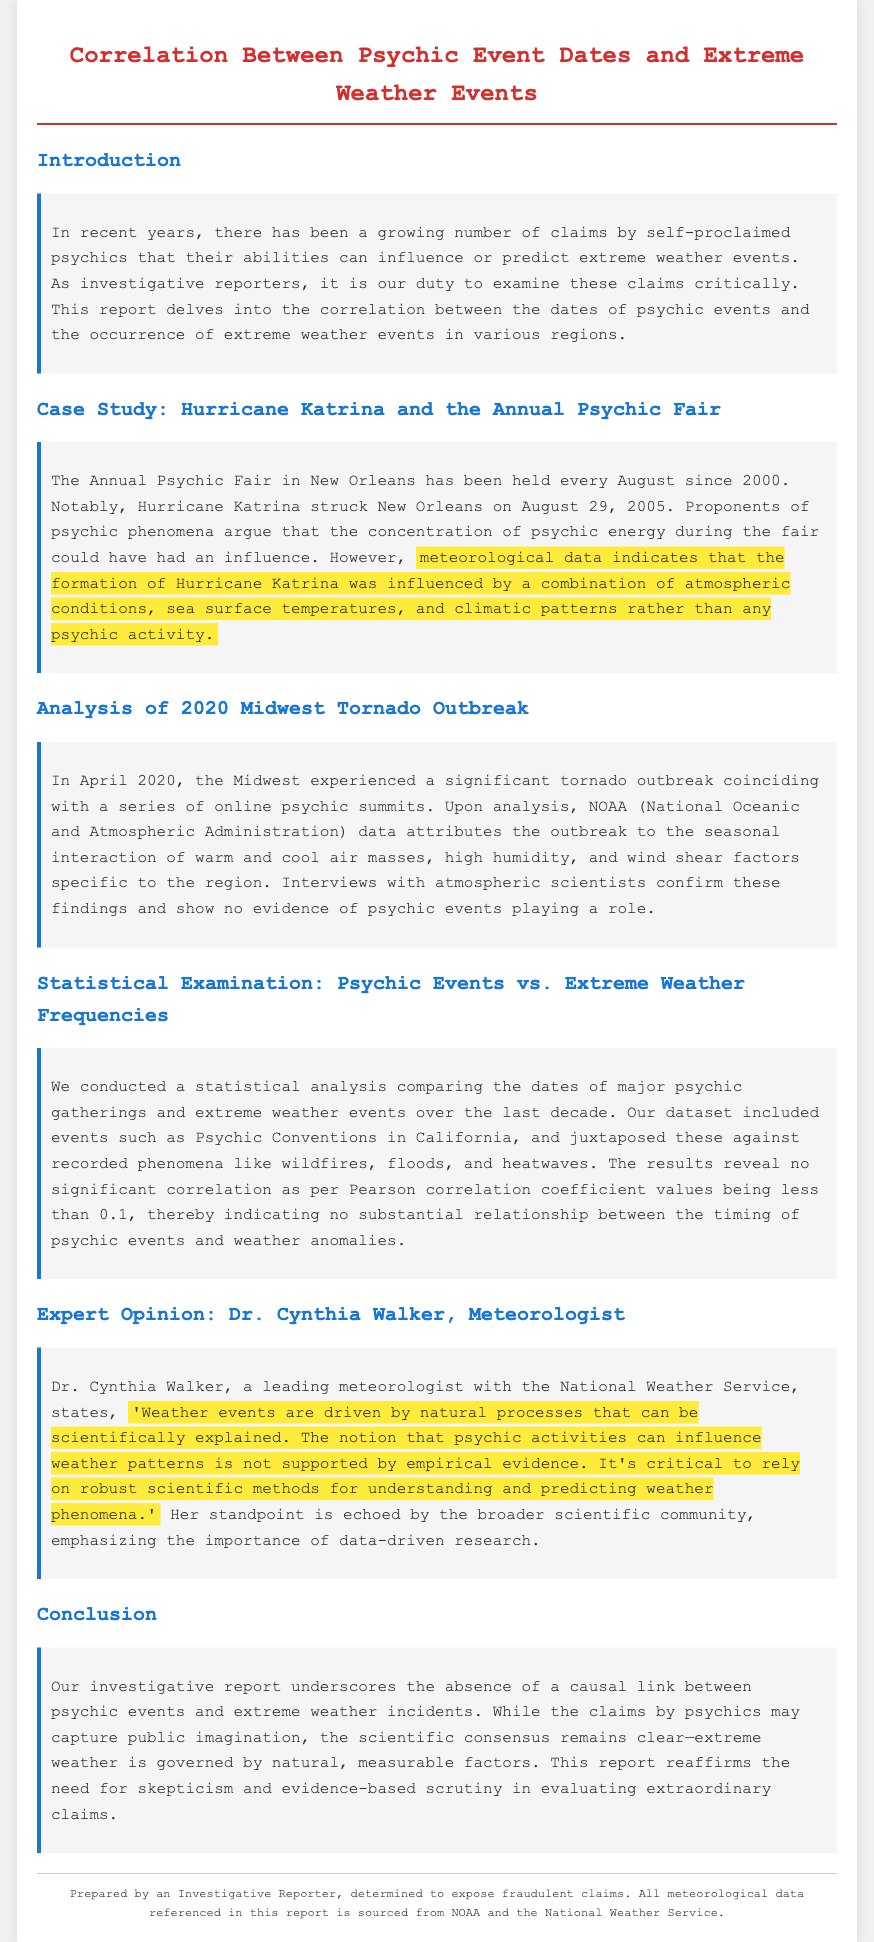What event coincided with Hurricane Katrina? The report indicates that Hurricane Katrina struck New Orleans on August 29, 2005, coinciding with the Annual Psychic Fair held every August since 2000.
Answer: Annual Psychic Fair What does the Pearson correlation coefficient indicate in this report? The report states that the Pearson correlation coefficient values being less than 0.1 indicate no substantial relationship between the timing of psychic events and weather anomalies.
Answer: Less than 0.1 Who is Dr. Cynthia Walker? Dr. Cynthia Walker is identified as a leading meteorologist with the National Weather Service in the document.
Answer: Leading meteorologist What significant weather event occurred in April 2020? The report mentions a significant tornado outbreak that took place in April 2020.
Answer: Tornado outbreak What is the main conclusion of the report? The conclusion emphasizes the absence of a causal link between psychic events and extreme weather incidents, reaffirming the importance of skepticism and evidence-based scrutiny.
Answer: Absence of causal link What is the title of the report? The title of the document is presented clearly at the top as "Correlation Between Psychic Event Dates and Extreme Weather Events."
Answer: Correlation Between Psychic Event Dates and Extreme Weather Events What season is associated with the 2020 Midwest Tornado Outbreak? The 2020 Midwest Tornado Outbreak, as indicated in the report, is associated with the spring season.
Answer: Spring season What type of events were analyzed statistically in the report? The report analyzed the dates of major psychic gatherings against recorded phenomena such as wildfires, floods, and heatwaves.
Answer: Psychic gatherings and extreme weather 